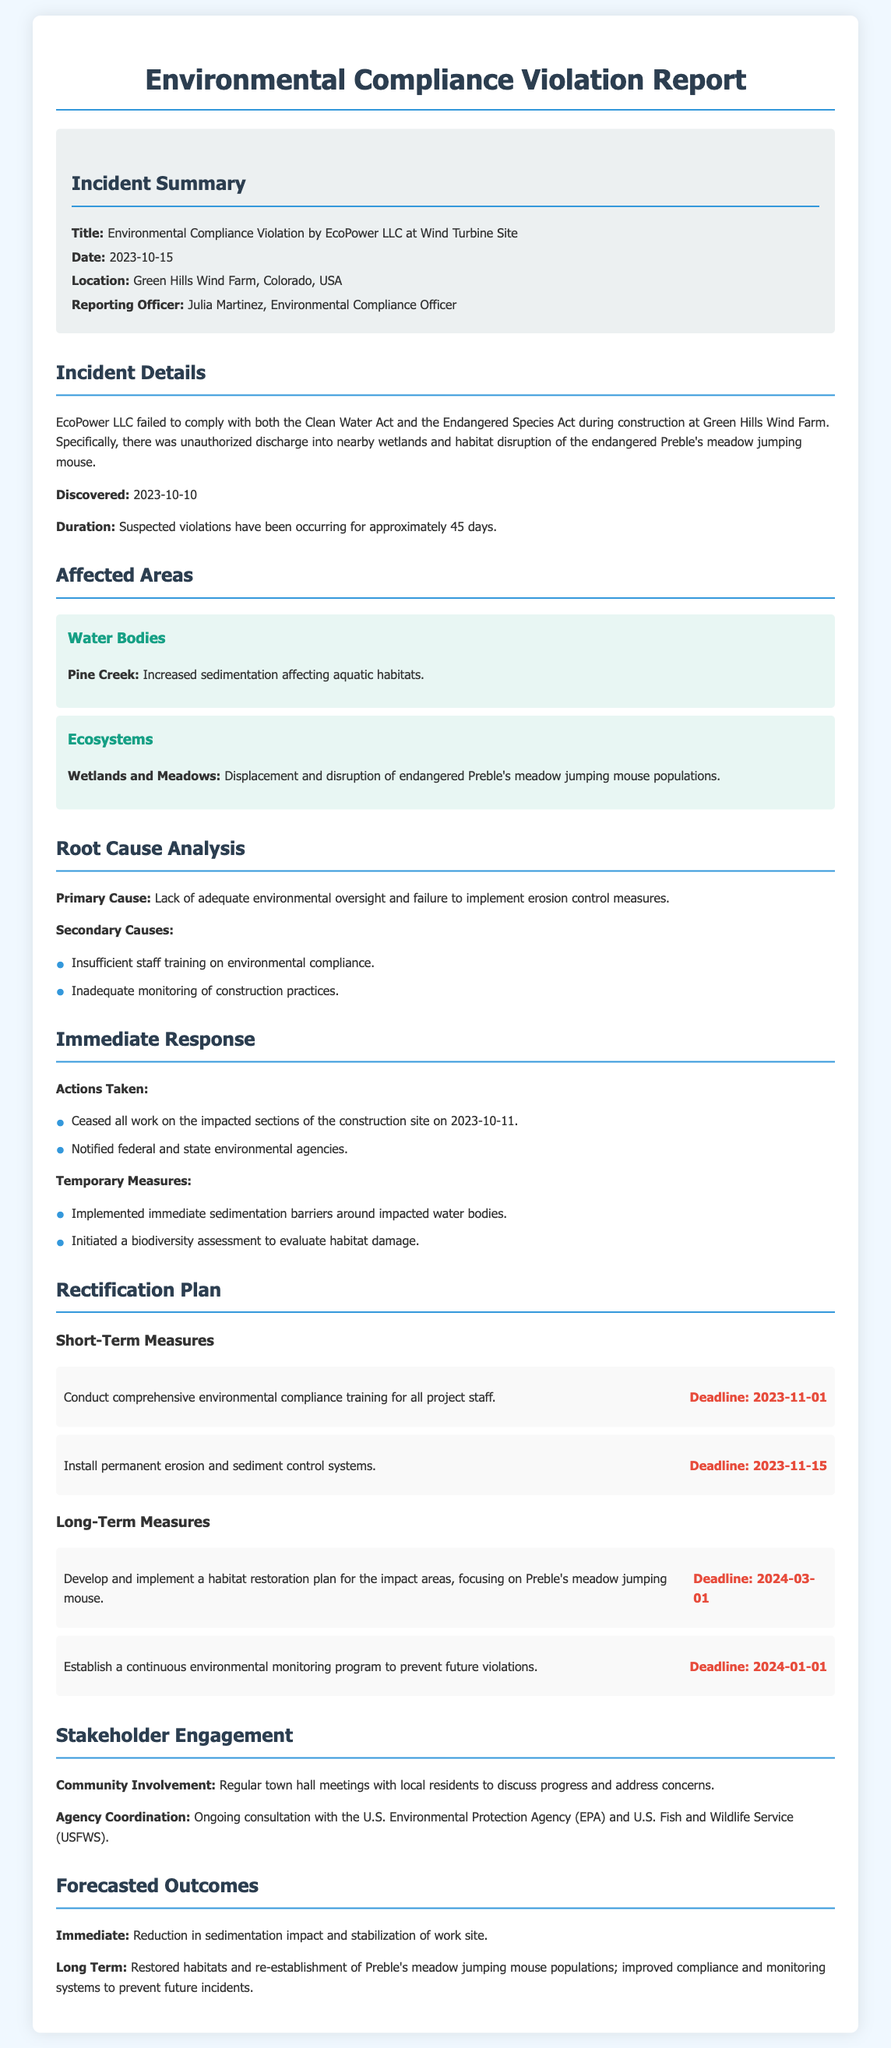What is the title of the incident report? The title is clearly stated in the summary section of the document.
Answer: Environmental Compliance Violation by EcoPower LLC at Wind Turbine Site Who is the reporting officer for this incident? The name of the reporting officer is mentioned in the incident summary section.
Answer: Julia Martinez When was the incident discovered? The date the incident was discovered is specified in the incident details.
Answer: 2023-10-10 What is the primary cause of the compliance violation? The primary cause is outlined in the root cause analysis section.
Answer: Lack of adequate environmental oversight and failure to implement erosion control measures What are the two short-term measures outlined in the rectification plan? The plans for rectification include specific short-term actions listed in the rectification plan section.
Answer: Conduct comprehensive environmental compliance training for all project staff, Install permanent erosion and sediment control systems Which endangered species was affected by the violation? The species that faced disruption is identified in the affected areas.
Answer: Preble's meadow jumping mouse What date is set for the long-term habitat restoration plan deadline? The deadline for the habitat restoration plan is mentioned in the long-term measures section.
Answer: 2024-03-01 What immediate action was taken on the site after the violation was discovered? The first actions undertaken to address the violation are recorded under immediate response.
Answer: Ceased all work on the impacted sections of the construction site on 2023-10-11 How long had the suspected violations been occurring? The duration of the suspected violations is specified in the incident details.
Answer: Approximately 45 days 